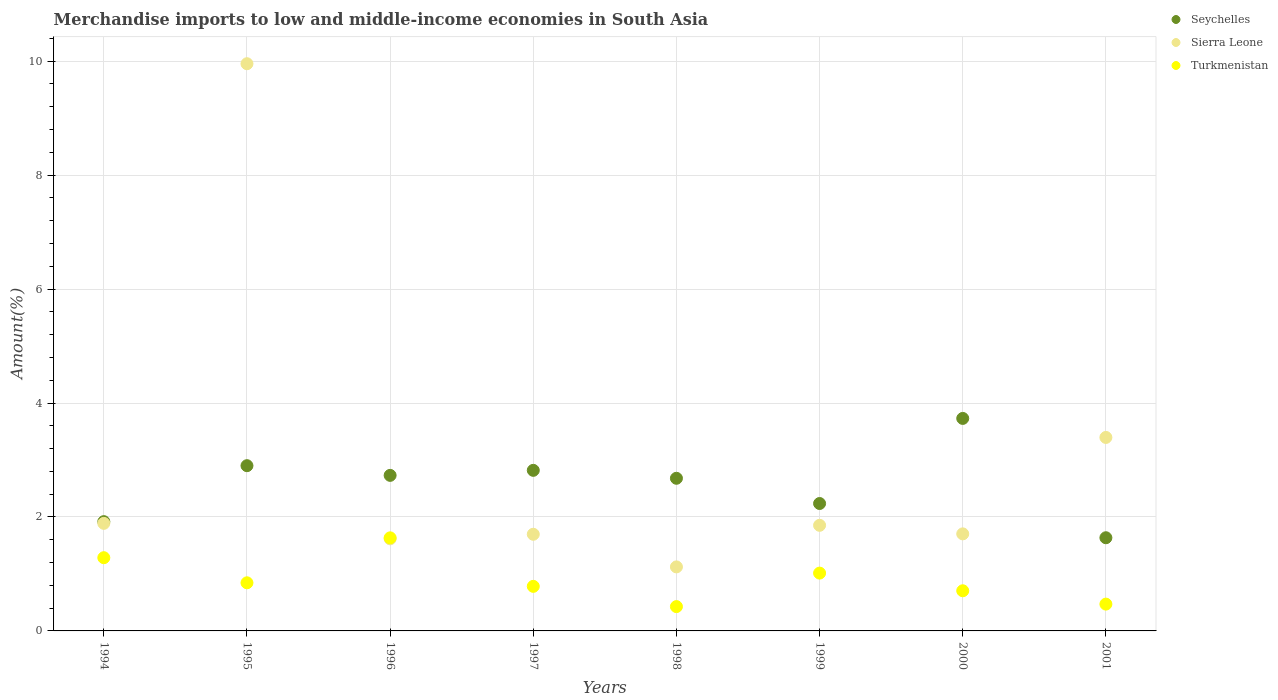How many different coloured dotlines are there?
Offer a terse response. 3. What is the percentage of amount earned from merchandise imports in Turkmenistan in 2000?
Your response must be concise. 0.7. Across all years, what is the maximum percentage of amount earned from merchandise imports in Sierra Leone?
Give a very brief answer. 9.96. Across all years, what is the minimum percentage of amount earned from merchandise imports in Turkmenistan?
Provide a short and direct response. 0.43. In which year was the percentage of amount earned from merchandise imports in Sierra Leone maximum?
Provide a short and direct response. 1995. What is the total percentage of amount earned from merchandise imports in Turkmenistan in the graph?
Give a very brief answer. 7.16. What is the difference between the percentage of amount earned from merchandise imports in Sierra Leone in 1996 and that in 1999?
Provide a succinct answer. -0.24. What is the difference between the percentage of amount earned from merchandise imports in Turkmenistan in 1994 and the percentage of amount earned from merchandise imports in Sierra Leone in 1997?
Ensure brevity in your answer.  -0.41. What is the average percentage of amount earned from merchandise imports in Turkmenistan per year?
Ensure brevity in your answer.  0.9. In the year 1994, what is the difference between the percentage of amount earned from merchandise imports in Seychelles and percentage of amount earned from merchandise imports in Sierra Leone?
Provide a succinct answer. 0.03. What is the ratio of the percentage of amount earned from merchandise imports in Turkmenistan in 1994 to that in 1996?
Provide a short and direct response. 0.79. Is the percentage of amount earned from merchandise imports in Sierra Leone in 1996 less than that in 2000?
Offer a terse response. Yes. What is the difference between the highest and the second highest percentage of amount earned from merchandise imports in Turkmenistan?
Provide a short and direct response. 0.35. What is the difference between the highest and the lowest percentage of amount earned from merchandise imports in Turkmenistan?
Offer a terse response. 1.21. In how many years, is the percentage of amount earned from merchandise imports in Seychelles greater than the average percentage of amount earned from merchandise imports in Seychelles taken over all years?
Provide a short and direct response. 5. Is it the case that in every year, the sum of the percentage of amount earned from merchandise imports in Seychelles and percentage of amount earned from merchandise imports in Sierra Leone  is greater than the percentage of amount earned from merchandise imports in Turkmenistan?
Ensure brevity in your answer.  Yes. Is the percentage of amount earned from merchandise imports in Sierra Leone strictly greater than the percentage of amount earned from merchandise imports in Turkmenistan over the years?
Ensure brevity in your answer.  No. Is the percentage of amount earned from merchandise imports in Seychelles strictly less than the percentage of amount earned from merchandise imports in Sierra Leone over the years?
Provide a short and direct response. No. What is the difference between two consecutive major ticks on the Y-axis?
Your answer should be compact. 2. How many legend labels are there?
Ensure brevity in your answer.  3. What is the title of the graph?
Offer a very short reply. Merchandise imports to low and middle-income economies in South Asia. Does "Algeria" appear as one of the legend labels in the graph?
Provide a short and direct response. No. What is the label or title of the X-axis?
Make the answer very short. Years. What is the label or title of the Y-axis?
Your answer should be very brief. Amount(%). What is the Amount(%) in Seychelles in 1994?
Provide a short and direct response. 1.92. What is the Amount(%) in Sierra Leone in 1994?
Make the answer very short. 1.89. What is the Amount(%) in Turkmenistan in 1994?
Your response must be concise. 1.29. What is the Amount(%) in Seychelles in 1995?
Make the answer very short. 2.9. What is the Amount(%) of Sierra Leone in 1995?
Offer a terse response. 9.96. What is the Amount(%) in Turkmenistan in 1995?
Give a very brief answer. 0.84. What is the Amount(%) of Seychelles in 1996?
Offer a terse response. 2.73. What is the Amount(%) of Sierra Leone in 1996?
Your answer should be compact. 1.62. What is the Amount(%) of Turkmenistan in 1996?
Provide a short and direct response. 1.63. What is the Amount(%) in Seychelles in 1997?
Provide a succinct answer. 2.82. What is the Amount(%) in Sierra Leone in 1997?
Keep it short and to the point. 1.7. What is the Amount(%) of Turkmenistan in 1997?
Provide a succinct answer. 0.78. What is the Amount(%) in Seychelles in 1998?
Make the answer very short. 2.68. What is the Amount(%) of Sierra Leone in 1998?
Make the answer very short. 1.12. What is the Amount(%) of Turkmenistan in 1998?
Provide a short and direct response. 0.43. What is the Amount(%) in Seychelles in 1999?
Provide a short and direct response. 2.24. What is the Amount(%) in Sierra Leone in 1999?
Give a very brief answer. 1.85. What is the Amount(%) of Turkmenistan in 1999?
Offer a very short reply. 1.01. What is the Amount(%) in Seychelles in 2000?
Provide a short and direct response. 3.73. What is the Amount(%) of Sierra Leone in 2000?
Make the answer very short. 1.7. What is the Amount(%) of Turkmenistan in 2000?
Your answer should be very brief. 0.7. What is the Amount(%) in Seychelles in 2001?
Keep it short and to the point. 1.64. What is the Amount(%) in Sierra Leone in 2001?
Provide a short and direct response. 3.4. What is the Amount(%) in Turkmenistan in 2001?
Give a very brief answer. 0.47. Across all years, what is the maximum Amount(%) of Seychelles?
Your answer should be very brief. 3.73. Across all years, what is the maximum Amount(%) of Sierra Leone?
Ensure brevity in your answer.  9.96. Across all years, what is the maximum Amount(%) of Turkmenistan?
Give a very brief answer. 1.63. Across all years, what is the minimum Amount(%) of Seychelles?
Give a very brief answer. 1.64. Across all years, what is the minimum Amount(%) in Sierra Leone?
Offer a very short reply. 1.12. Across all years, what is the minimum Amount(%) of Turkmenistan?
Provide a short and direct response. 0.43. What is the total Amount(%) of Seychelles in the graph?
Keep it short and to the point. 20.65. What is the total Amount(%) in Sierra Leone in the graph?
Your response must be concise. 23.23. What is the total Amount(%) in Turkmenistan in the graph?
Keep it short and to the point. 7.16. What is the difference between the Amount(%) of Seychelles in 1994 and that in 1995?
Provide a succinct answer. -0.98. What is the difference between the Amount(%) in Sierra Leone in 1994 and that in 1995?
Your answer should be compact. -8.07. What is the difference between the Amount(%) in Turkmenistan in 1994 and that in 1995?
Provide a succinct answer. 0.44. What is the difference between the Amount(%) of Seychelles in 1994 and that in 1996?
Provide a succinct answer. -0.81. What is the difference between the Amount(%) in Sierra Leone in 1994 and that in 1996?
Your response must be concise. 0.27. What is the difference between the Amount(%) of Turkmenistan in 1994 and that in 1996?
Give a very brief answer. -0.35. What is the difference between the Amount(%) of Seychelles in 1994 and that in 1997?
Offer a terse response. -0.9. What is the difference between the Amount(%) of Sierra Leone in 1994 and that in 1997?
Offer a terse response. 0.19. What is the difference between the Amount(%) in Turkmenistan in 1994 and that in 1997?
Your response must be concise. 0.5. What is the difference between the Amount(%) of Seychelles in 1994 and that in 1998?
Make the answer very short. -0.76. What is the difference between the Amount(%) in Sierra Leone in 1994 and that in 1998?
Make the answer very short. 0.76. What is the difference between the Amount(%) of Turkmenistan in 1994 and that in 1998?
Provide a short and direct response. 0.86. What is the difference between the Amount(%) of Seychelles in 1994 and that in 1999?
Offer a terse response. -0.32. What is the difference between the Amount(%) in Sierra Leone in 1994 and that in 1999?
Provide a short and direct response. 0.03. What is the difference between the Amount(%) in Turkmenistan in 1994 and that in 1999?
Offer a terse response. 0.27. What is the difference between the Amount(%) in Seychelles in 1994 and that in 2000?
Offer a very short reply. -1.81. What is the difference between the Amount(%) of Sierra Leone in 1994 and that in 2000?
Your answer should be compact. 0.18. What is the difference between the Amount(%) in Turkmenistan in 1994 and that in 2000?
Your response must be concise. 0.58. What is the difference between the Amount(%) of Seychelles in 1994 and that in 2001?
Provide a succinct answer. 0.28. What is the difference between the Amount(%) in Sierra Leone in 1994 and that in 2001?
Offer a very short reply. -1.51. What is the difference between the Amount(%) in Turkmenistan in 1994 and that in 2001?
Your answer should be compact. 0.81. What is the difference between the Amount(%) in Seychelles in 1995 and that in 1996?
Ensure brevity in your answer.  0.17. What is the difference between the Amount(%) in Sierra Leone in 1995 and that in 1996?
Make the answer very short. 8.34. What is the difference between the Amount(%) in Turkmenistan in 1995 and that in 1996?
Make the answer very short. -0.79. What is the difference between the Amount(%) of Seychelles in 1995 and that in 1997?
Ensure brevity in your answer.  0.08. What is the difference between the Amount(%) of Sierra Leone in 1995 and that in 1997?
Make the answer very short. 8.26. What is the difference between the Amount(%) in Turkmenistan in 1995 and that in 1997?
Provide a succinct answer. 0.06. What is the difference between the Amount(%) of Seychelles in 1995 and that in 1998?
Your response must be concise. 0.22. What is the difference between the Amount(%) of Sierra Leone in 1995 and that in 1998?
Make the answer very short. 8.83. What is the difference between the Amount(%) of Turkmenistan in 1995 and that in 1998?
Give a very brief answer. 0.42. What is the difference between the Amount(%) in Seychelles in 1995 and that in 1999?
Give a very brief answer. 0.66. What is the difference between the Amount(%) in Sierra Leone in 1995 and that in 1999?
Your answer should be very brief. 8.1. What is the difference between the Amount(%) in Turkmenistan in 1995 and that in 1999?
Your response must be concise. -0.17. What is the difference between the Amount(%) in Seychelles in 1995 and that in 2000?
Offer a very short reply. -0.83. What is the difference between the Amount(%) in Sierra Leone in 1995 and that in 2000?
Ensure brevity in your answer.  8.25. What is the difference between the Amount(%) in Turkmenistan in 1995 and that in 2000?
Ensure brevity in your answer.  0.14. What is the difference between the Amount(%) in Seychelles in 1995 and that in 2001?
Offer a very short reply. 1.26. What is the difference between the Amount(%) in Sierra Leone in 1995 and that in 2001?
Give a very brief answer. 6.56. What is the difference between the Amount(%) in Turkmenistan in 1995 and that in 2001?
Offer a terse response. 0.37. What is the difference between the Amount(%) of Seychelles in 1996 and that in 1997?
Provide a succinct answer. -0.09. What is the difference between the Amount(%) in Sierra Leone in 1996 and that in 1997?
Your answer should be compact. -0.08. What is the difference between the Amount(%) in Turkmenistan in 1996 and that in 1997?
Your answer should be very brief. 0.85. What is the difference between the Amount(%) of Seychelles in 1996 and that in 1998?
Your answer should be compact. 0.05. What is the difference between the Amount(%) in Sierra Leone in 1996 and that in 1998?
Keep it short and to the point. 0.49. What is the difference between the Amount(%) in Turkmenistan in 1996 and that in 1998?
Offer a very short reply. 1.21. What is the difference between the Amount(%) of Seychelles in 1996 and that in 1999?
Keep it short and to the point. 0.49. What is the difference between the Amount(%) in Sierra Leone in 1996 and that in 1999?
Give a very brief answer. -0.24. What is the difference between the Amount(%) in Turkmenistan in 1996 and that in 1999?
Your answer should be very brief. 0.62. What is the difference between the Amount(%) of Seychelles in 1996 and that in 2000?
Make the answer very short. -1. What is the difference between the Amount(%) of Sierra Leone in 1996 and that in 2000?
Offer a terse response. -0.09. What is the difference between the Amount(%) in Turkmenistan in 1996 and that in 2000?
Provide a succinct answer. 0.93. What is the difference between the Amount(%) of Seychelles in 1996 and that in 2001?
Make the answer very short. 1.09. What is the difference between the Amount(%) of Sierra Leone in 1996 and that in 2001?
Give a very brief answer. -1.78. What is the difference between the Amount(%) in Turkmenistan in 1996 and that in 2001?
Your answer should be very brief. 1.16. What is the difference between the Amount(%) in Seychelles in 1997 and that in 1998?
Ensure brevity in your answer.  0.14. What is the difference between the Amount(%) of Sierra Leone in 1997 and that in 1998?
Offer a very short reply. 0.57. What is the difference between the Amount(%) in Turkmenistan in 1997 and that in 1998?
Offer a very short reply. 0.36. What is the difference between the Amount(%) of Seychelles in 1997 and that in 1999?
Offer a terse response. 0.58. What is the difference between the Amount(%) in Sierra Leone in 1997 and that in 1999?
Your response must be concise. -0.16. What is the difference between the Amount(%) of Turkmenistan in 1997 and that in 1999?
Provide a succinct answer. -0.23. What is the difference between the Amount(%) of Seychelles in 1997 and that in 2000?
Ensure brevity in your answer.  -0.91. What is the difference between the Amount(%) of Sierra Leone in 1997 and that in 2000?
Make the answer very short. -0.01. What is the difference between the Amount(%) in Turkmenistan in 1997 and that in 2000?
Offer a very short reply. 0.08. What is the difference between the Amount(%) of Seychelles in 1997 and that in 2001?
Provide a succinct answer. 1.18. What is the difference between the Amount(%) in Sierra Leone in 1997 and that in 2001?
Your response must be concise. -1.7. What is the difference between the Amount(%) of Turkmenistan in 1997 and that in 2001?
Offer a terse response. 0.31. What is the difference between the Amount(%) of Seychelles in 1998 and that in 1999?
Make the answer very short. 0.44. What is the difference between the Amount(%) of Sierra Leone in 1998 and that in 1999?
Provide a short and direct response. -0.73. What is the difference between the Amount(%) of Turkmenistan in 1998 and that in 1999?
Your answer should be compact. -0.59. What is the difference between the Amount(%) in Seychelles in 1998 and that in 2000?
Offer a very short reply. -1.05. What is the difference between the Amount(%) of Sierra Leone in 1998 and that in 2000?
Ensure brevity in your answer.  -0.58. What is the difference between the Amount(%) in Turkmenistan in 1998 and that in 2000?
Give a very brief answer. -0.28. What is the difference between the Amount(%) of Seychelles in 1998 and that in 2001?
Keep it short and to the point. 1.04. What is the difference between the Amount(%) in Sierra Leone in 1998 and that in 2001?
Your response must be concise. -2.27. What is the difference between the Amount(%) of Turkmenistan in 1998 and that in 2001?
Ensure brevity in your answer.  -0.04. What is the difference between the Amount(%) in Seychelles in 1999 and that in 2000?
Your answer should be compact. -1.49. What is the difference between the Amount(%) in Turkmenistan in 1999 and that in 2000?
Give a very brief answer. 0.31. What is the difference between the Amount(%) of Seychelles in 1999 and that in 2001?
Provide a short and direct response. 0.6. What is the difference between the Amount(%) of Sierra Leone in 1999 and that in 2001?
Provide a short and direct response. -1.54. What is the difference between the Amount(%) in Turkmenistan in 1999 and that in 2001?
Offer a very short reply. 0.54. What is the difference between the Amount(%) in Seychelles in 2000 and that in 2001?
Your response must be concise. 2.09. What is the difference between the Amount(%) in Sierra Leone in 2000 and that in 2001?
Keep it short and to the point. -1.69. What is the difference between the Amount(%) in Turkmenistan in 2000 and that in 2001?
Ensure brevity in your answer.  0.23. What is the difference between the Amount(%) in Seychelles in 1994 and the Amount(%) in Sierra Leone in 1995?
Ensure brevity in your answer.  -8.04. What is the difference between the Amount(%) of Seychelles in 1994 and the Amount(%) of Turkmenistan in 1995?
Make the answer very short. 1.07. What is the difference between the Amount(%) of Sierra Leone in 1994 and the Amount(%) of Turkmenistan in 1995?
Make the answer very short. 1.04. What is the difference between the Amount(%) in Seychelles in 1994 and the Amount(%) in Sierra Leone in 1996?
Keep it short and to the point. 0.3. What is the difference between the Amount(%) in Seychelles in 1994 and the Amount(%) in Turkmenistan in 1996?
Your response must be concise. 0.28. What is the difference between the Amount(%) in Sierra Leone in 1994 and the Amount(%) in Turkmenistan in 1996?
Your response must be concise. 0.25. What is the difference between the Amount(%) of Seychelles in 1994 and the Amount(%) of Sierra Leone in 1997?
Offer a very short reply. 0.22. What is the difference between the Amount(%) of Seychelles in 1994 and the Amount(%) of Turkmenistan in 1997?
Your response must be concise. 1.14. What is the difference between the Amount(%) of Sierra Leone in 1994 and the Amount(%) of Turkmenistan in 1997?
Ensure brevity in your answer.  1.11. What is the difference between the Amount(%) of Seychelles in 1994 and the Amount(%) of Sierra Leone in 1998?
Provide a succinct answer. 0.79. What is the difference between the Amount(%) in Seychelles in 1994 and the Amount(%) in Turkmenistan in 1998?
Ensure brevity in your answer.  1.49. What is the difference between the Amount(%) in Sierra Leone in 1994 and the Amount(%) in Turkmenistan in 1998?
Your response must be concise. 1.46. What is the difference between the Amount(%) in Seychelles in 1994 and the Amount(%) in Sierra Leone in 1999?
Provide a succinct answer. 0.06. What is the difference between the Amount(%) in Seychelles in 1994 and the Amount(%) in Turkmenistan in 1999?
Keep it short and to the point. 0.9. What is the difference between the Amount(%) of Sierra Leone in 1994 and the Amount(%) of Turkmenistan in 1999?
Your answer should be very brief. 0.87. What is the difference between the Amount(%) of Seychelles in 1994 and the Amount(%) of Sierra Leone in 2000?
Make the answer very short. 0.21. What is the difference between the Amount(%) of Seychelles in 1994 and the Amount(%) of Turkmenistan in 2000?
Keep it short and to the point. 1.21. What is the difference between the Amount(%) of Sierra Leone in 1994 and the Amount(%) of Turkmenistan in 2000?
Offer a terse response. 1.18. What is the difference between the Amount(%) of Seychelles in 1994 and the Amount(%) of Sierra Leone in 2001?
Your response must be concise. -1.48. What is the difference between the Amount(%) in Seychelles in 1994 and the Amount(%) in Turkmenistan in 2001?
Your answer should be very brief. 1.45. What is the difference between the Amount(%) of Sierra Leone in 1994 and the Amount(%) of Turkmenistan in 2001?
Your response must be concise. 1.42. What is the difference between the Amount(%) in Seychelles in 1995 and the Amount(%) in Sierra Leone in 1996?
Make the answer very short. 1.28. What is the difference between the Amount(%) in Seychelles in 1995 and the Amount(%) in Turkmenistan in 1996?
Make the answer very short. 1.27. What is the difference between the Amount(%) of Sierra Leone in 1995 and the Amount(%) of Turkmenistan in 1996?
Your answer should be compact. 8.32. What is the difference between the Amount(%) of Seychelles in 1995 and the Amount(%) of Sierra Leone in 1997?
Your answer should be very brief. 1.2. What is the difference between the Amount(%) of Seychelles in 1995 and the Amount(%) of Turkmenistan in 1997?
Provide a short and direct response. 2.12. What is the difference between the Amount(%) in Sierra Leone in 1995 and the Amount(%) in Turkmenistan in 1997?
Provide a succinct answer. 9.17. What is the difference between the Amount(%) of Seychelles in 1995 and the Amount(%) of Sierra Leone in 1998?
Provide a succinct answer. 1.78. What is the difference between the Amount(%) of Seychelles in 1995 and the Amount(%) of Turkmenistan in 1998?
Make the answer very short. 2.47. What is the difference between the Amount(%) in Sierra Leone in 1995 and the Amount(%) in Turkmenistan in 1998?
Give a very brief answer. 9.53. What is the difference between the Amount(%) of Seychelles in 1995 and the Amount(%) of Sierra Leone in 1999?
Your answer should be compact. 1.05. What is the difference between the Amount(%) of Seychelles in 1995 and the Amount(%) of Turkmenistan in 1999?
Ensure brevity in your answer.  1.89. What is the difference between the Amount(%) in Sierra Leone in 1995 and the Amount(%) in Turkmenistan in 1999?
Your response must be concise. 8.94. What is the difference between the Amount(%) in Seychelles in 1995 and the Amount(%) in Sierra Leone in 2000?
Make the answer very short. 1.2. What is the difference between the Amount(%) in Seychelles in 1995 and the Amount(%) in Turkmenistan in 2000?
Keep it short and to the point. 2.2. What is the difference between the Amount(%) of Sierra Leone in 1995 and the Amount(%) of Turkmenistan in 2000?
Your response must be concise. 9.25. What is the difference between the Amount(%) of Seychelles in 1995 and the Amount(%) of Sierra Leone in 2001?
Your response must be concise. -0.5. What is the difference between the Amount(%) of Seychelles in 1995 and the Amount(%) of Turkmenistan in 2001?
Provide a succinct answer. 2.43. What is the difference between the Amount(%) of Sierra Leone in 1995 and the Amount(%) of Turkmenistan in 2001?
Offer a terse response. 9.48. What is the difference between the Amount(%) of Seychelles in 1996 and the Amount(%) of Sierra Leone in 1997?
Offer a very short reply. 1.03. What is the difference between the Amount(%) in Seychelles in 1996 and the Amount(%) in Turkmenistan in 1997?
Keep it short and to the point. 1.95. What is the difference between the Amount(%) in Sierra Leone in 1996 and the Amount(%) in Turkmenistan in 1997?
Your answer should be very brief. 0.83. What is the difference between the Amount(%) in Seychelles in 1996 and the Amount(%) in Sierra Leone in 1998?
Your answer should be compact. 1.61. What is the difference between the Amount(%) of Seychelles in 1996 and the Amount(%) of Turkmenistan in 1998?
Make the answer very short. 2.3. What is the difference between the Amount(%) of Sierra Leone in 1996 and the Amount(%) of Turkmenistan in 1998?
Make the answer very short. 1.19. What is the difference between the Amount(%) in Seychelles in 1996 and the Amount(%) in Sierra Leone in 1999?
Provide a short and direct response. 0.88. What is the difference between the Amount(%) in Seychelles in 1996 and the Amount(%) in Turkmenistan in 1999?
Give a very brief answer. 1.72. What is the difference between the Amount(%) of Sierra Leone in 1996 and the Amount(%) of Turkmenistan in 1999?
Provide a short and direct response. 0.6. What is the difference between the Amount(%) in Seychelles in 1996 and the Amount(%) in Sierra Leone in 2000?
Your response must be concise. 1.03. What is the difference between the Amount(%) of Seychelles in 1996 and the Amount(%) of Turkmenistan in 2000?
Ensure brevity in your answer.  2.03. What is the difference between the Amount(%) of Sierra Leone in 1996 and the Amount(%) of Turkmenistan in 2000?
Ensure brevity in your answer.  0.91. What is the difference between the Amount(%) of Seychelles in 1996 and the Amount(%) of Sierra Leone in 2001?
Your response must be concise. -0.67. What is the difference between the Amount(%) in Seychelles in 1996 and the Amount(%) in Turkmenistan in 2001?
Your answer should be compact. 2.26. What is the difference between the Amount(%) in Sierra Leone in 1996 and the Amount(%) in Turkmenistan in 2001?
Your answer should be compact. 1.15. What is the difference between the Amount(%) in Seychelles in 1997 and the Amount(%) in Sierra Leone in 1998?
Give a very brief answer. 1.69. What is the difference between the Amount(%) of Seychelles in 1997 and the Amount(%) of Turkmenistan in 1998?
Your answer should be very brief. 2.39. What is the difference between the Amount(%) of Sierra Leone in 1997 and the Amount(%) of Turkmenistan in 1998?
Make the answer very short. 1.27. What is the difference between the Amount(%) in Seychelles in 1997 and the Amount(%) in Sierra Leone in 1999?
Offer a very short reply. 0.96. What is the difference between the Amount(%) of Seychelles in 1997 and the Amount(%) of Turkmenistan in 1999?
Give a very brief answer. 1.8. What is the difference between the Amount(%) in Sierra Leone in 1997 and the Amount(%) in Turkmenistan in 1999?
Offer a terse response. 0.68. What is the difference between the Amount(%) in Seychelles in 1997 and the Amount(%) in Sierra Leone in 2000?
Provide a short and direct response. 1.11. What is the difference between the Amount(%) in Seychelles in 1997 and the Amount(%) in Turkmenistan in 2000?
Provide a succinct answer. 2.11. What is the difference between the Amount(%) of Seychelles in 1997 and the Amount(%) of Sierra Leone in 2001?
Keep it short and to the point. -0.58. What is the difference between the Amount(%) of Seychelles in 1997 and the Amount(%) of Turkmenistan in 2001?
Your answer should be very brief. 2.35. What is the difference between the Amount(%) of Sierra Leone in 1997 and the Amount(%) of Turkmenistan in 2001?
Offer a very short reply. 1.23. What is the difference between the Amount(%) in Seychelles in 1998 and the Amount(%) in Sierra Leone in 1999?
Make the answer very short. 0.83. What is the difference between the Amount(%) of Seychelles in 1998 and the Amount(%) of Turkmenistan in 1999?
Ensure brevity in your answer.  1.66. What is the difference between the Amount(%) in Sierra Leone in 1998 and the Amount(%) in Turkmenistan in 1999?
Ensure brevity in your answer.  0.11. What is the difference between the Amount(%) of Seychelles in 1998 and the Amount(%) of Sierra Leone in 2000?
Keep it short and to the point. 0.98. What is the difference between the Amount(%) of Seychelles in 1998 and the Amount(%) of Turkmenistan in 2000?
Provide a succinct answer. 1.97. What is the difference between the Amount(%) in Sierra Leone in 1998 and the Amount(%) in Turkmenistan in 2000?
Give a very brief answer. 0.42. What is the difference between the Amount(%) in Seychelles in 1998 and the Amount(%) in Sierra Leone in 2001?
Your response must be concise. -0.72. What is the difference between the Amount(%) of Seychelles in 1998 and the Amount(%) of Turkmenistan in 2001?
Your answer should be very brief. 2.21. What is the difference between the Amount(%) in Sierra Leone in 1998 and the Amount(%) in Turkmenistan in 2001?
Your answer should be compact. 0.65. What is the difference between the Amount(%) in Seychelles in 1999 and the Amount(%) in Sierra Leone in 2000?
Make the answer very short. 0.53. What is the difference between the Amount(%) of Seychelles in 1999 and the Amount(%) of Turkmenistan in 2000?
Your answer should be compact. 1.53. What is the difference between the Amount(%) in Sierra Leone in 1999 and the Amount(%) in Turkmenistan in 2000?
Your answer should be compact. 1.15. What is the difference between the Amount(%) of Seychelles in 1999 and the Amount(%) of Sierra Leone in 2001?
Ensure brevity in your answer.  -1.16. What is the difference between the Amount(%) of Seychelles in 1999 and the Amount(%) of Turkmenistan in 2001?
Provide a short and direct response. 1.77. What is the difference between the Amount(%) of Sierra Leone in 1999 and the Amount(%) of Turkmenistan in 2001?
Your answer should be very brief. 1.38. What is the difference between the Amount(%) of Seychelles in 2000 and the Amount(%) of Sierra Leone in 2001?
Ensure brevity in your answer.  0.33. What is the difference between the Amount(%) in Seychelles in 2000 and the Amount(%) in Turkmenistan in 2001?
Your response must be concise. 3.26. What is the difference between the Amount(%) in Sierra Leone in 2000 and the Amount(%) in Turkmenistan in 2001?
Offer a very short reply. 1.23. What is the average Amount(%) in Seychelles per year?
Give a very brief answer. 2.58. What is the average Amount(%) of Sierra Leone per year?
Make the answer very short. 2.9. What is the average Amount(%) in Turkmenistan per year?
Your answer should be very brief. 0.9. In the year 1994, what is the difference between the Amount(%) of Seychelles and Amount(%) of Sierra Leone?
Provide a succinct answer. 0.03. In the year 1994, what is the difference between the Amount(%) in Seychelles and Amount(%) in Turkmenistan?
Offer a terse response. 0.63. In the year 1994, what is the difference between the Amount(%) in Sierra Leone and Amount(%) in Turkmenistan?
Provide a short and direct response. 0.6. In the year 1995, what is the difference between the Amount(%) of Seychelles and Amount(%) of Sierra Leone?
Offer a very short reply. -7.06. In the year 1995, what is the difference between the Amount(%) in Seychelles and Amount(%) in Turkmenistan?
Provide a short and direct response. 2.06. In the year 1995, what is the difference between the Amount(%) in Sierra Leone and Amount(%) in Turkmenistan?
Provide a short and direct response. 9.11. In the year 1996, what is the difference between the Amount(%) in Seychelles and Amount(%) in Sierra Leone?
Your answer should be compact. 1.11. In the year 1996, what is the difference between the Amount(%) of Seychelles and Amount(%) of Turkmenistan?
Make the answer very short. 1.1. In the year 1996, what is the difference between the Amount(%) of Sierra Leone and Amount(%) of Turkmenistan?
Give a very brief answer. -0.02. In the year 1997, what is the difference between the Amount(%) in Seychelles and Amount(%) in Sierra Leone?
Your response must be concise. 1.12. In the year 1997, what is the difference between the Amount(%) of Seychelles and Amount(%) of Turkmenistan?
Provide a succinct answer. 2.04. In the year 1997, what is the difference between the Amount(%) in Sierra Leone and Amount(%) in Turkmenistan?
Give a very brief answer. 0.91. In the year 1998, what is the difference between the Amount(%) of Seychelles and Amount(%) of Sierra Leone?
Offer a very short reply. 1.56. In the year 1998, what is the difference between the Amount(%) in Seychelles and Amount(%) in Turkmenistan?
Offer a very short reply. 2.25. In the year 1998, what is the difference between the Amount(%) in Sierra Leone and Amount(%) in Turkmenistan?
Keep it short and to the point. 0.7. In the year 1999, what is the difference between the Amount(%) in Seychelles and Amount(%) in Sierra Leone?
Ensure brevity in your answer.  0.38. In the year 1999, what is the difference between the Amount(%) of Seychelles and Amount(%) of Turkmenistan?
Offer a very short reply. 1.22. In the year 1999, what is the difference between the Amount(%) of Sierra Leone and Amount(%) of Turkmenistan?
Provide a succinct answer. 0.84. In the year 2000, what is the difference between the Amount(%) in Seychelles and Amount(%) in Sierra Leone?
Provide a short and direct response. 2.03. In the year 2000, what is the difference between the Amount(%) in Seychelles and Amount(%) in Turkmenistan?
Offer a very short reply. 3.02. In the year 2001, what is the difference between the Amount(%) of Seychelles and Amount(%) of Sierra Leone?
Keep it short and to the point. -1.76. In the year 2001, what is the difference between the Amount(%) of Seychelles and Amount(%) of Turkmenistan?
Provide a succinct answer. 1.16. In the year 2001, what is the difference between the Amount(%) of Sierra Leone and Amount(%) of Turkmenistan?
Your answer should be very brief. 2.93. What is the ratio of the Amount(%) in Seychelles in 1994 to that in 1995?
Provide a succinct answer. 0.66. What is the ratio of the Amount(%) of Sierra Leone in 1994 to that in 1995?
Make the answer very short. 0.19. What is the ratio of the Amount(%) of Turkmenistan in 1994 to that in 1995?
Keep it short and to the point. 1.52. What is the ratio of the Amount(%) in Seychelles in 1994 to that in 1996?
Your answer should be compact. 0.7. What is the ratio of the Amount(%) in Sierra Leone in 1994 to that in 1996?
Keep it short and to the point. 1.17. What is the ratio of the Amount(%) in Turkmenistan in 1994 to that in 1996?
Keep it short and to the point. 0.79. What is the ratio of the Amount(%) in Seychelles in 1994 to that in 1997?
Make the answer very short. 0.68. What is the ratio of the Amount(%) in Sierra Leone in 1994 to that in 1997?
Keep it short and to the point. 1.11. What is the ratio of the Amount(%) of Turkmenistan in 1994 to that in 1997?
Your answer should be compact. 1.64. What is the ratio of the Amount(%) in Seychelles in 1994 to that in 1998?
Your answer should be very brief. 0.72. What is the ratio of the Amount(%) in Sierra Leone in 1994 to that in 1998?
Offer a very short reply. 1.68. What is the ratio of the Amount(%) in Turkmenistan in 1994 to that in 1998?
Provide a short and direct response. 3.01. What is the ratio of the Amount(%) of Seychelles in 1994 to that in 1999?
Offer a very short reply. 0.86. What is the ratio of the Amount(%) in Sierra Leone in 1994 to that in 1999?
Your response must be concise. 1.02. What is the ratio of the Amount(%) in Turkmenistan in 1994 to that in 1999?
Provide a succinct answer. 1.27. What is the ratio of the Amount(%) in Seychelles in 1994 to that in 2000?
Ensure brevity in your answer.  0.51. What is the ratio of the Amount(%) of Sierra Leone in 1994 to that in 2000?
Your response must be concise. 1.11. What is the ratio of the Amount(%) of Turkmenistan in 1994 to that in 2000?
Ensure brevity in your answer.  1.82. What is the ratio of the Amount(%) of Seychelles in 1994 to that in 2001?
Provide a succinct answer. 1.17. What is the ratio of the Amount(%) in Sierra Leone in 1994 to that in 2001?
Offer a very short reply. 0.56. What is the ratio of the Amount(%) in Turkmenistan in 1994 to that in 2001?
Your answer should be compact. 2.73. What is the ratio of the Amount(%) of Seychelles in 1995 to that in 1996?
Your answer should be very brief. 1.06. What is the ratio of the Amount(%) of Sierra Leone in 1995 to that in 1996?
Ensure brevity in your answer.  6.16. What is the ratio of the Amount(%) in Turkmenistan in 1995 to that in 1996?
Offer a terse response. 0.52. What is the ratio of the Amount(%) in Seychelles in 1995 to that in 1997?
Give a very brief answer. 1.03. What is the ratio of the Amount(%) of Sierra Leone in 1995 to that in 1997?
Your answer should be very brief. 5.87. What is the ratio of the Amount(%) in Turkmenistan in 1995 to that in 1997?
Offer a terse response. 1.08. What is the ratio of the Amount(%) in Seychelles in 1995 to that in 1998?
Provide a succinct answer. 1.08. What is the ratio of the Amount(%) of Sierra Leone in 1995 to that in 1998?
Provide a short and direct response. 8.86. What is the ratio of the Amount(%) in Turkmenistan in 1995 to that in 1998?
Keep it short and to the point. 1.98. What is the ratio of the Amount(%) of Seychelles in 1995 to that in 1999?
Provide a short and direct response. 1.3. What is the ratio of the Amount(%) of Sierra Leone in 1995 to that in 1999?
Ensure brevity in your answer.  5.37. What is the ratio of the Amount(%) of Turkmenistan in 1995 to that in 1999?
Offer a very short reply. 0.83. What is the ratio of the Amount(%) in Seychelles in 1995 to that in 2000?
Keep it short and to the point. 0.78. What is the ratio of the Amount(%) in Sierra Leone in 1995 to that in 2000?
Your response must be concise. 5.84. What is the ratio of the Amount(%) in Turkmenistan in 1995 to that in 2000?
Keep it short and to the point. 1.2. What is the ratio of the Amount(%) in Seychelles in 1995 to that in 2001?
Keep it short and to the point. 1.77. What is the ratio of the Amount(%) of Sierra Leone in 1995 to that in 2001?
Offer a terse response. 2.93. What is the ratio of the Amount(%) in Turkmenistan in 1995 to that in 2001?
Your response must be concise. 1.79. What is the ratio of the Amount(%) in Seychelles in 1996 to that in 1997?
Ensure brevity in your answer.  0.97. What is the ratio of the Amount(%) of Sierra Leone in 1996 to that in 1997?
Ensure brevity in your answer.  0.95. What is the ratio of the Amount(%) in Turkmenistan in 1996 to that in 1997?
Provide a short and direct response. 2.09. What is the ratio of the Amount(%) of Seychelles in 1996 to that in 1998?
Make the answer very short. 1.02. What is the ratio of the Amount(%) in Sierra Leone in 1996 to that in 1998?
Your answer should be very brief. 1.44. What is the ratio of the Amount(%) of Turkmenistan in 1996 to that in 1998?
Your response must be concise. 3.83. What is the ratio of the Amount(%) in Seychelles in 1996 to that in 1999?
Offer a very short reply. 1.22. What is the ratio of the Amount(%) in Sierra Leone in 1996 to that in 1999?
Your response must be concise. 0.87. What is the ratio of the Amount(%) of Turkmenistan in 1996 to that in 1999?
Offer a terse response. 1.61. What is the ratio of the Amount(%) of Seychelles in 1996 to that in 2000?
Give a very brief answer. 0.73. What is the ratio of the Amount(%) in Sierra Leone in 1996 to that in 2000?
Give a very brief answer. 0.95. What is the ratio of the Amount(%) of Turkmenistan in 1996 to that in 2000?
Provide a succinct answer. 2.32. What is the ratio of the Amount(%) in Seychelles in 1996 to that in 2001?
Your answer should be very brief. 1.67. What is the ratio of the Amount(%) of Sierra Leone in 1996 to that in 2001?
Your response must be concise. 0.48. What is the ratio of the Amount(%) in Turkmenistan in 1996 to that in 2001?
Provide a short and direct response. 3.47. What is the ratio of the Amount(%) of Seychelles in 1997 to that in 1998?
Keep it short and to the point. 1.05. What is the ratio of the Amount(%) in Sierra Leone in 1997 to that in 1998?
Make the answer very short. 1.51. What is the ratio of the Amount(%) in Turkmenistan in 1997 to that in 1998?
Your answer should be very brief. 1.83. What is the ratio of the Amount(%) in Seychelles in 1997 to that in 1999?
Your response must be concise. 1.26. What is the ratio of the Amount(%) of Sierra Leone in 1997 to that in 1999?
Your answer should be very brief. 0.92. What is the ratio of the Amount(%) in Turkmenistan in 1997 to that in 1999?
Your response must be concise. 0.77. What is the ratio of the Amount(%) of Seychelles in 1997 to that in 2000?
Give a very brief answer. 0.76. What is the ratio of the Amount(%) in Sierra Leone in 1997 to that in 2000?
Give a very brief answer. 1. What is the ratio of the Amount(%) of Turkmenistan in 1997 to that in 2000?
Ensure brevity in your answer.  1.11. What is the ratio of the Amount(%) of Seychelles in 1997 to that in 2001?
Give a very brief answer. 1.72. What is the ratio of the Amount(%) in Sierra Leone in 1997 to that in 2001?
Give a very brief answer. 0.5. What is the ratio of the Amount(%) in Turkmenistan in 1997 to that in 2001?
Provide a succinct answer. 1.66. What is the ratio of the Amount(%) in Seychelles in 1998 to that in 1999?
Ensure brevity in your answer.  1.2. What is the ratio of the Amount(%) of Sierra Leone in 1998 to that in 1999?
Your answer should be very brief. 0.61. What is the ratio of the Amount(%) of Turkmenistan in 1998 to that in 1999?
Your answer should be very brief. 0.42. What is the ratio of the Amount(%) of Seychelles in 1998 to that in 2000?
Offer a terse response. 0.72. What is the ratio of the Amount(%) in Sierra Leone in 1998 to that in 2000?
Provide a short and direct response. 0.66. What is the ratio of the Amount(%) of Turkmenistan in 1998 to that in 2000?
Your response must be concise. 0.61. What is the ratio of the Amount(%) in Seychelles in 1998 to that in 2001?
Provide a short and direct response. 1.64. What is the ratio of the Amount(%) of Sierra Leone in 1998 to that in 2001?
Offer a terse response. 0.33. What is the ratio of the Amount(%) of Turkmenistan in 1998 to that in 2001?
Ensure brevity in your answer.  0.91. What is the ratio of the Amount(%) of Seychelles in 1999 to that in 2000?
Give a very brief answer. 0.6. What is the ratio of the Amount(%) of Sierra Leone in 1999 to that in 2000?
Offer a very short reply. 1.09. What is the ratio of the Amount(%) in Turkmenistan in 1999 to that in 2000?
Provide a short and direct response. 1.44. What is the ratio of the Amount(%) in Seychelles in 1999 to that in 2001?
Your answer should be very brief. 1.37. What is the ratio of the Amount(%) in Sierra Leone in 1999 to that in 2001?
Your answer should be very brief. 0.55. What is the ratio of the Amount(%) in Turkmenistan in 1999 to that in 2001?
Offer a very short reply. 2.16. What is the ratio of the Amount(%) in Seychelles in 2000 to that in 2001?
Your answer should be very brief. 2.28. What is the ratio of the Amount(%) in Sierra Leone in 2000 to that in 2001?
Give a very brief answer. 0.5. What is the ratio of the Amount(%) of Turkmenistan in 2000 to that in 2001?
Your response must be concise. 1.5. What is the difference between the highest and the second highest Amount(%) in Seychelles?
Provide a succinct answer. 0.83. What is the difference between the highest and the second highest Amount(%) of Sierra Leone?
Make the answer very short. 6.56. What is the difference between the highest and the second highest Amount(%) in Turkmenistan?
Offer a very short reply. 0.35. What is the difference between the highest and the lowest Amount(%) of Seychelles?
Provide a succinct answer. 2.09. What is the difference between the highest and the lowest Amount(%) in Sierra Leone?
Keep it short and to the point. 8.83. What is the difference between the highest and the lowest Amount(%) of Turkmenistan?
Your answer should be compact. 1.21. 